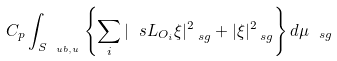<formula> <loc_0><loc_0><loc_500><loc_500>C _ { p } \int _ { S _ { \ u b , u } } \left \{ \sum _ { i } | \ s L _ { O _ { i } } \xi | ^ { 2 } _ { \ s g } + | \xi | ^ { 2 } _ { \ s g } \right \} d \mu _ { \ s g }</formula> 